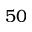<formula> <loc_0><loc_0><loc_500><loc_500>5 0</formula> 